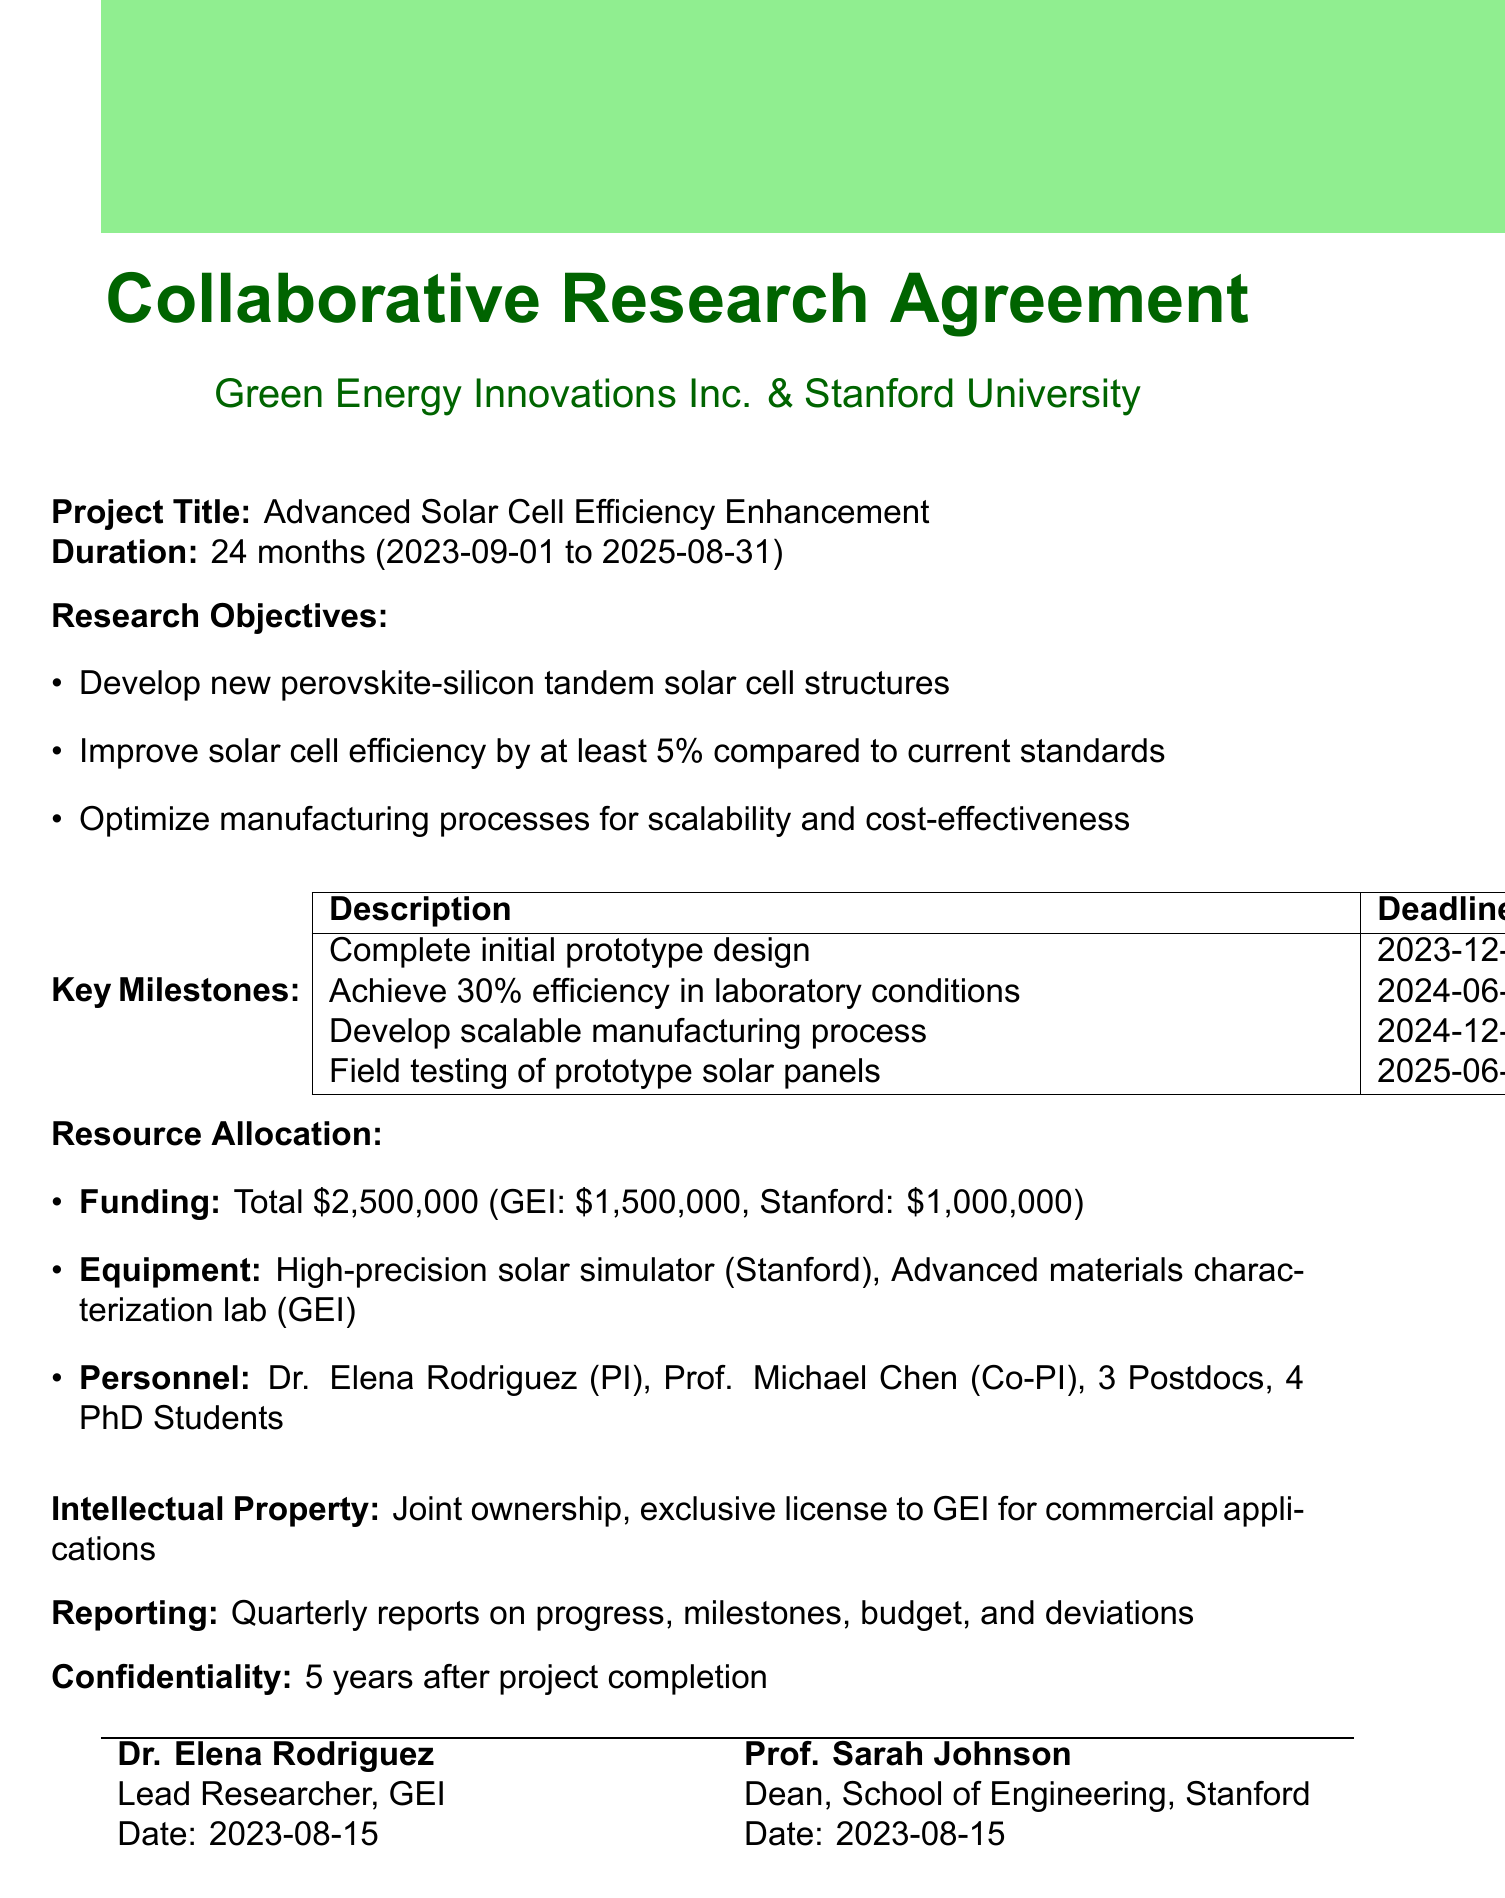What is the project title? The project title is explicitly stated in the document under "Project Title."
Answer: Advanced Solar Cell Efficiency Enhancement Who is the Lead Researcher? The Lead Researcher is listed in the "Personnel" section with the role and name specified.
Answer: Dr. Elena Rodriguez What is the total funding amount for the project? The total funding amount is provided in the "Funding" section of the resource allocation.
Answer: $2,500,000 What is the deadline for achieving 30% efficiency in laboratory conditions? This deadline is mentioned in the "Key Milestones" section, detailing project progress expectations.
Answer: 2024-06-30 How many PhD Students are allocated to the project? The number of PhD students is provided in the "Personnel" section of the resource allocation.
Answer: 4 What is the reporting frequency required in the agreement? The reporting frequency is clearly stated in the "Reporting Requirements" section.
Answer: Quarterly What are the conditions for termination of the contract? The conditions are specified under "Termination Clause," which outlines multiple scenarios that can lead to termination.
Answer: Mutual agreement, Breach of contract, Inability to achieve key milestones Who retains the publication rights for research findings? This information is given in the "Intellectual Property" section and defines the rights of the involved parties.
Answer: Stanford University 